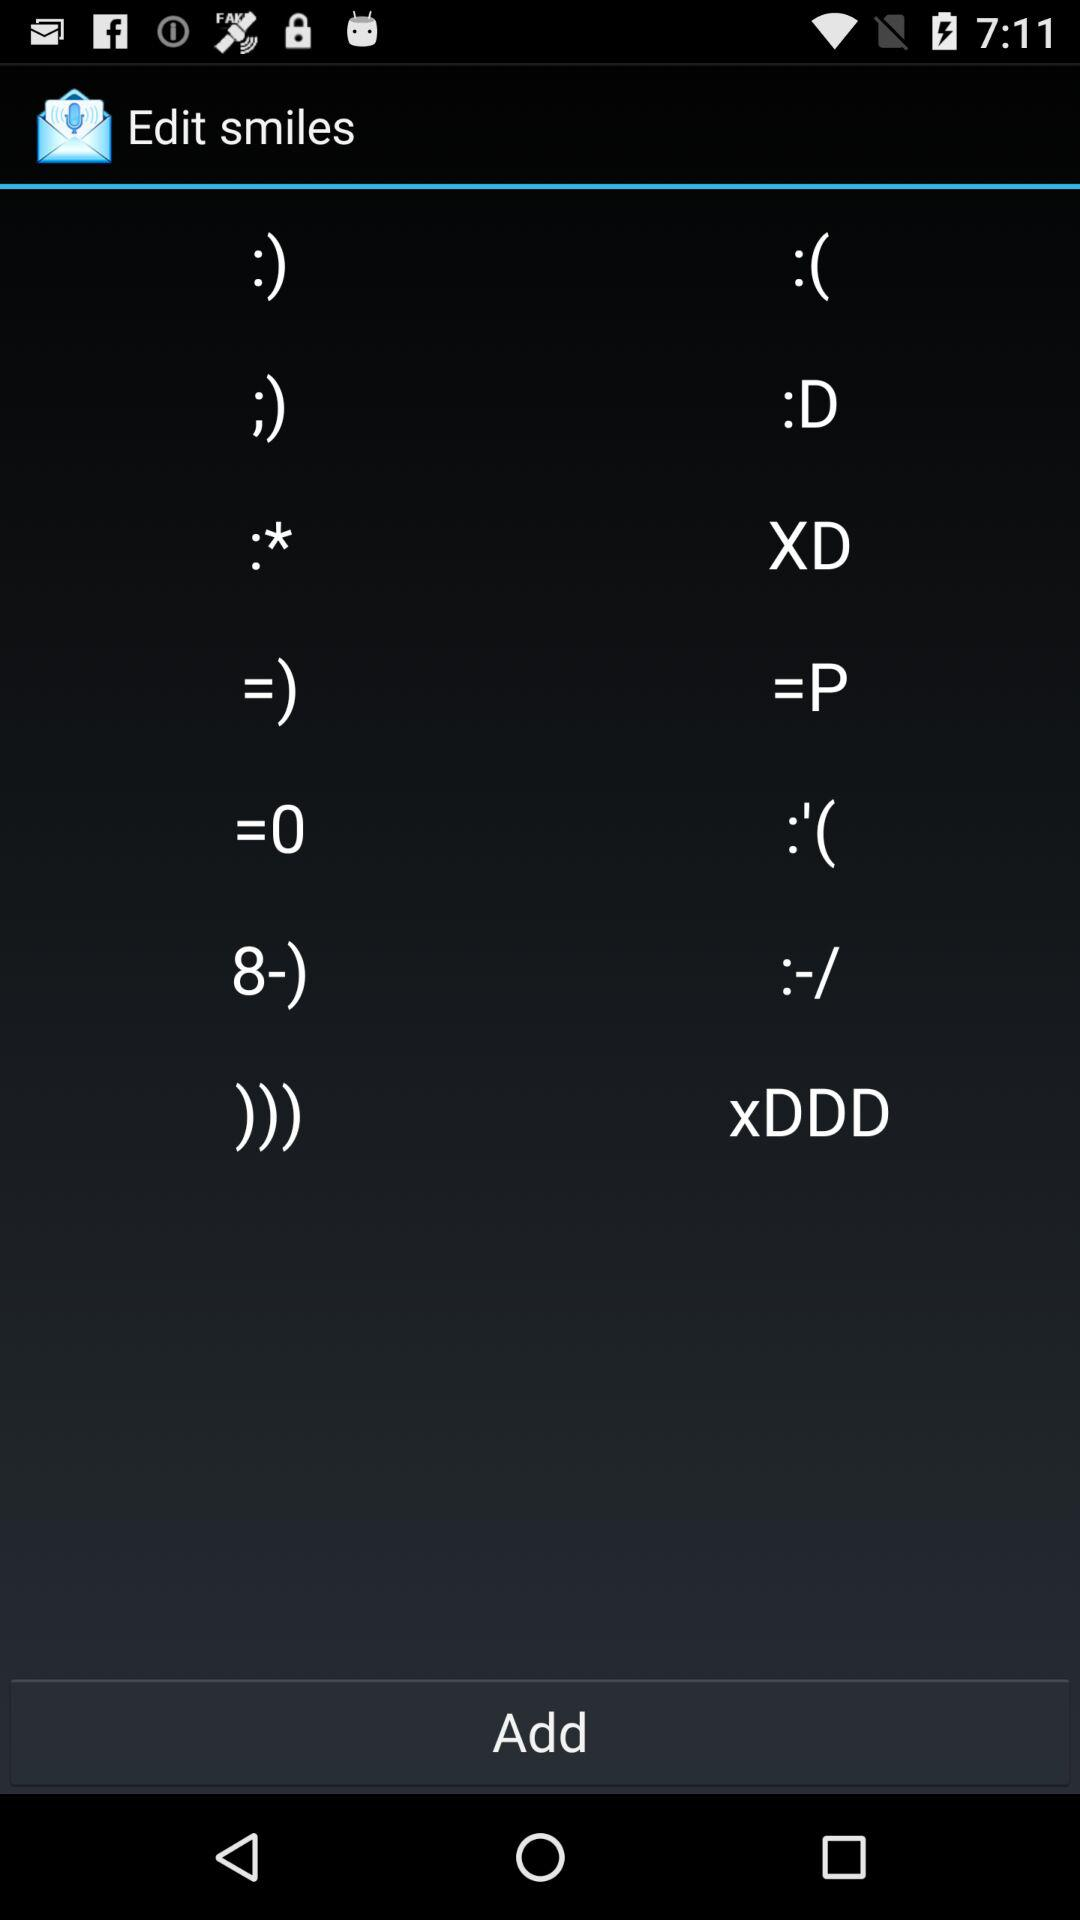Which smiles are edited?
When the provided information is insufficient, respond with <no answer>. <no answer> 